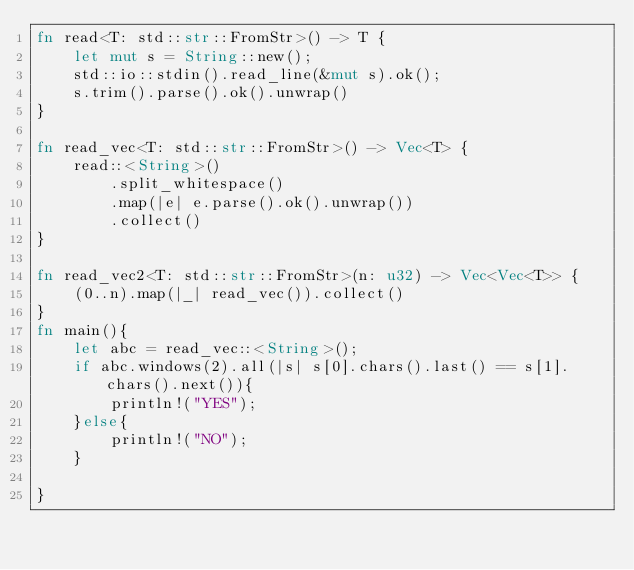Convert code to text. <code><loc_0><loc_0><loc_500><loc_500><_Rust_>fn read<T: std::str::FromStr>() -> T {
    let mut s = String::new();
    std::io::stdin().read_line(&mut s).ok();
    s.trim().parse().ok().unwrap()
}

fn read_vec<T: std::str::FromStr>() -> Vec<T> {
    read::<String>()
        .split_whitespace()
        .map(|e| e.parse().ok().unwrap())
        .collect()
}

fn read_vec2<T: std::str::FromStr>(n: u32) -> Vec<Vec<T>> {
    (0..n).map(|_| read_vec()).collect()
}
fn main(){
    let abc = read_vec::<String>();
    if abc.windows(2).all(|s| s[0].chars().last() == s[1].chars().next()){
        println!("YES");
    }else{
        println!("NO");
    }
    
}</code> 